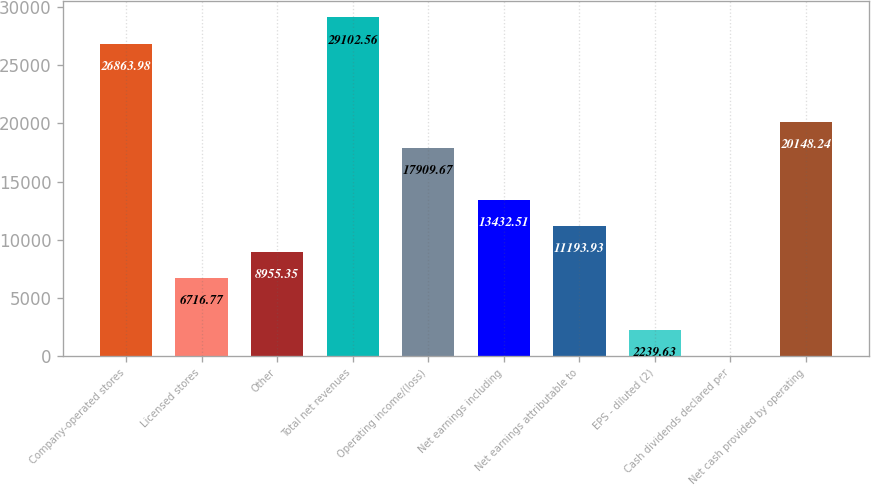Convert chart. <chart><loc_0><loc_0><loc_500><loc_500><bar_chart><fcel>Company-operated stores<fcel>Licensed stores<fcel>Other<fcel>Total net revenues<fcel>Operating income/(loss)<fcel>Net earnings including<fcel>Net earnings attributable to<fcel>EPS - diluted (2)<fcel>Cash dividends declared per<fcel>Net cash provided by operating<nl><fcel>26864<fcel>6716.77<fcel>8955.35<fcel>29102.6<fcel>17909.7<fcel>13432.5<fcel>11193.9<fcel>2239.63<fcel>1.05<fcel>20148.2<nl></chart> 